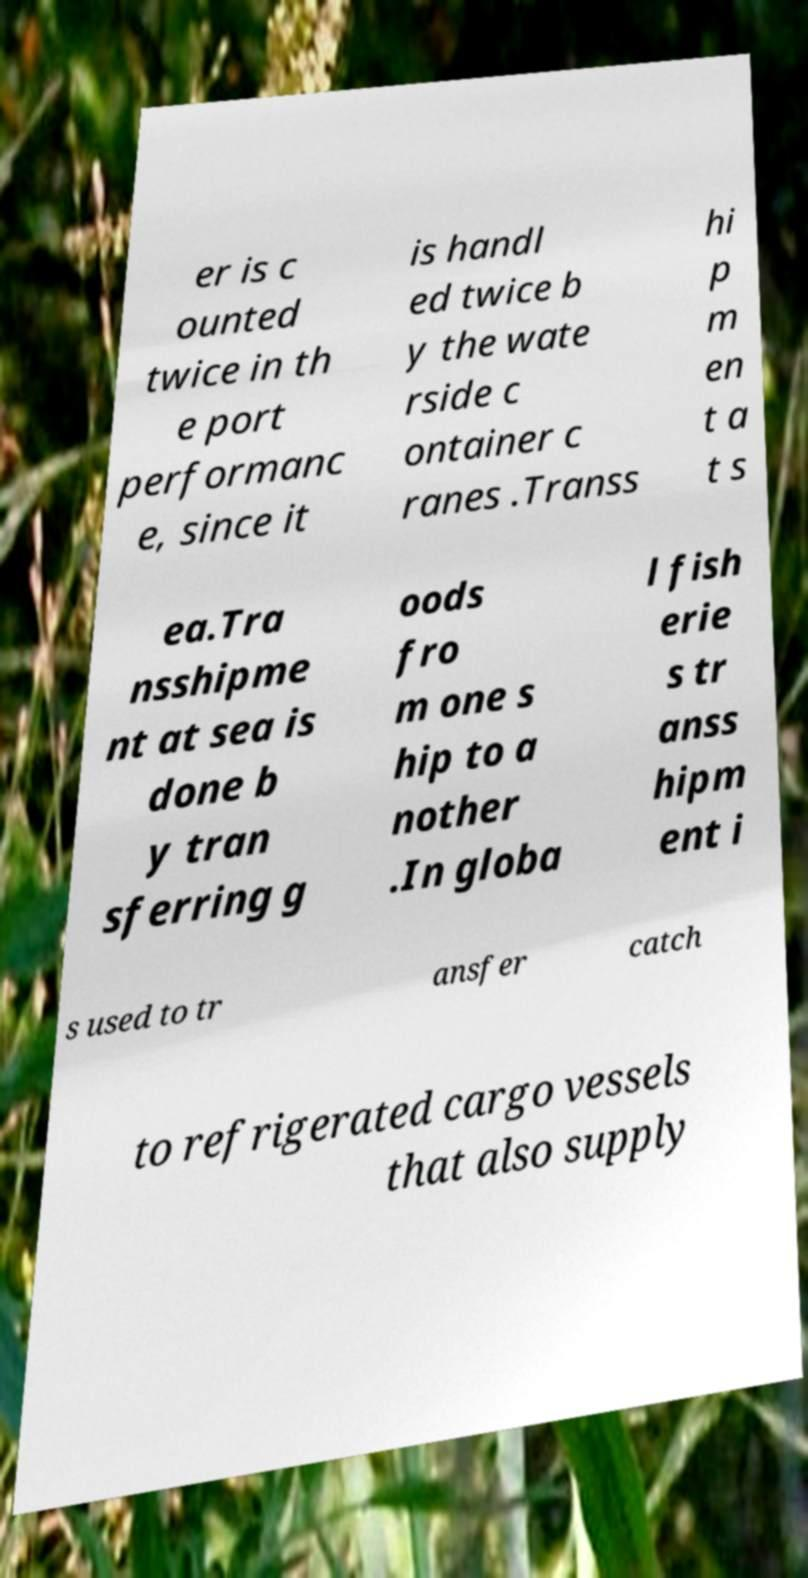Can you accurately transcribe the text from the provided image for me? er is c ounted twice in th e port performanc e, since it is handl ed twice b y the wate rside c ontainer c ranes .Transs hi p m en t a t s ea.Tra nsshipme nt at sea is done b y tran sferring g oods fro m one s hip to a nother .In globa l fish erie s tr anss hipm ent i s used to tr ansfer catch to refrigerated cargo vessels that also supply 